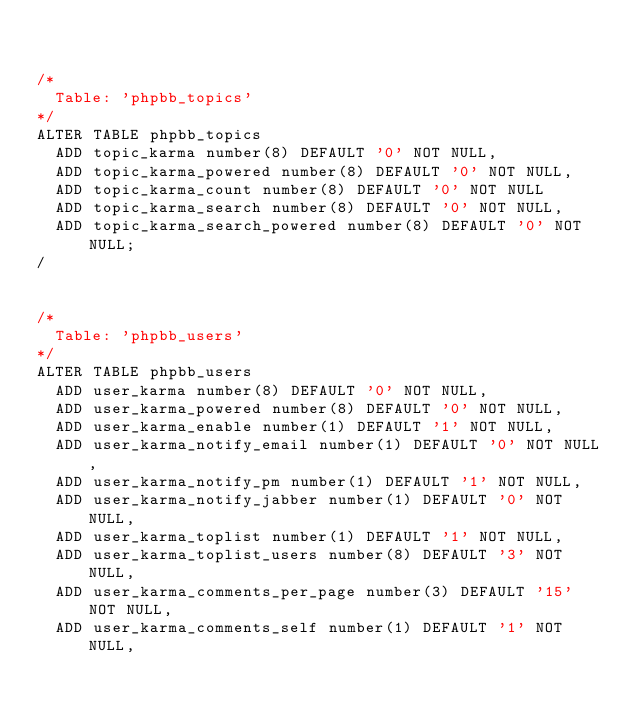Convert code to text. <code><loc_0><loc_0><loc_500><loc_500><_SQL_>

/*
	Table: 'phpbb_topics'
*/
ALTER TABLE phpbb_topics
	ADD topic_karma number(8) DEFAULT '0' NOT NULL,
	ADD topic_karma_powered number(8) DEFAULT '0' NOT NULL,
	ADD topic_karma_count number(8) DEFAULT '0' NOT NULL
	ADD topic_karma_search number(8) DEFAULT '0' NOT NULL,
	ADD topic_karma_search_powered number(8) DEFAULT '0' NOT NULL;
/


/*
	Table: 'phpbb_users'
*/
ALTER TABLE phpbb_users
	ADD user_karma number(8) DEFAULT '0' NOT NULL,
	ADD user_karma_powered number(8) DEFAULT '0' NOT NULL,
	ADD user_karma_enable number(1) DEFAULT '1' NOT NULL,
	ADD user_karma_notify_email number(1) DEFAULT '0' NOT NULL,
	ADD user_karma_notify_pm number(1) DEFAULT '1' NOT NULL,
	ADD user_karma_notify_jabber number(1) DEFAULT '0' NOT NULL,
	ADD user_karma_toplist number(1) DEFAULT '1' NOT NULL,
	ADD user_karma_toplist_users number(8) DEFAULT '3' NOT NULL,
	ADD user_karma_comments_per_page number(3) DEFAULT '15' NOT NULL,
	ADD user_karma_comments_self number(1) DEFAULT '1' NOT NULL,</code> 